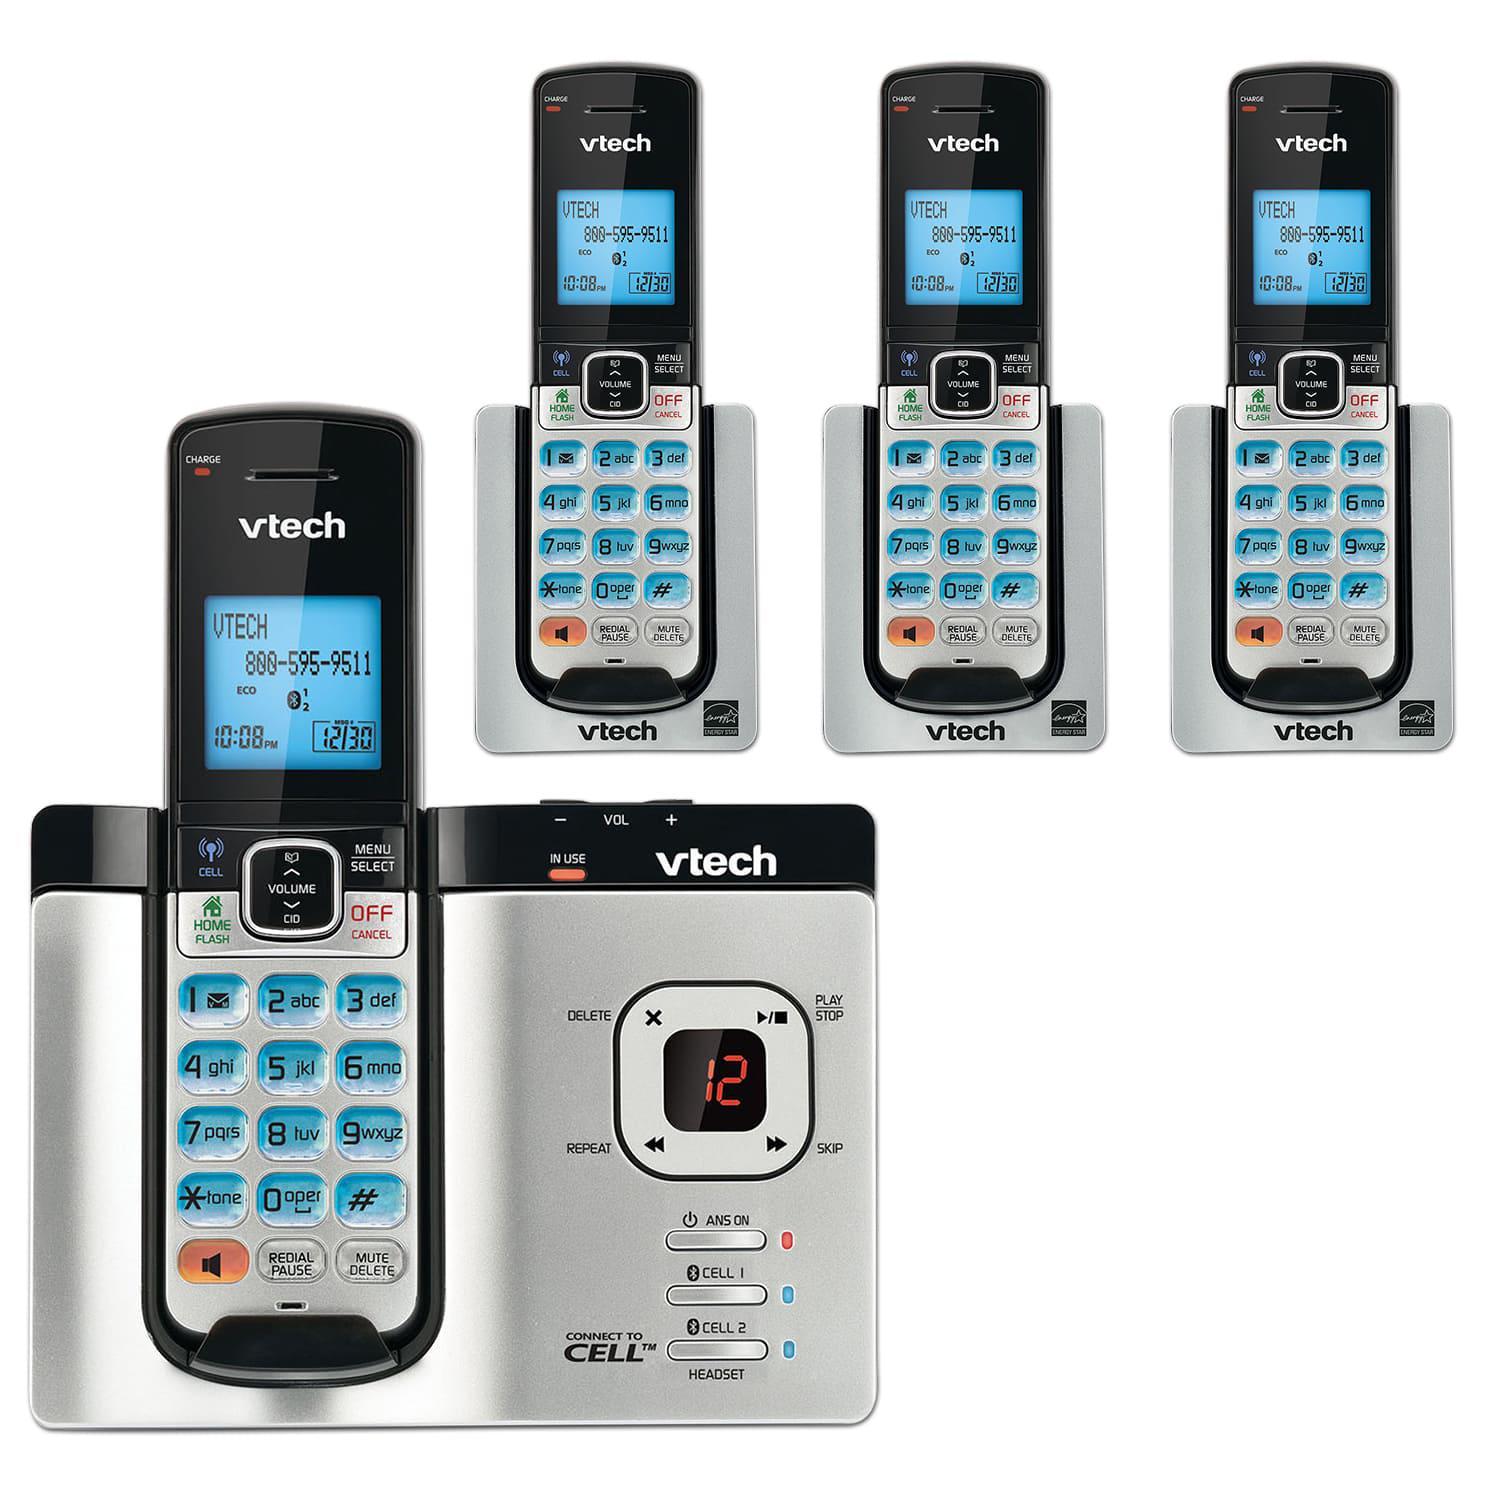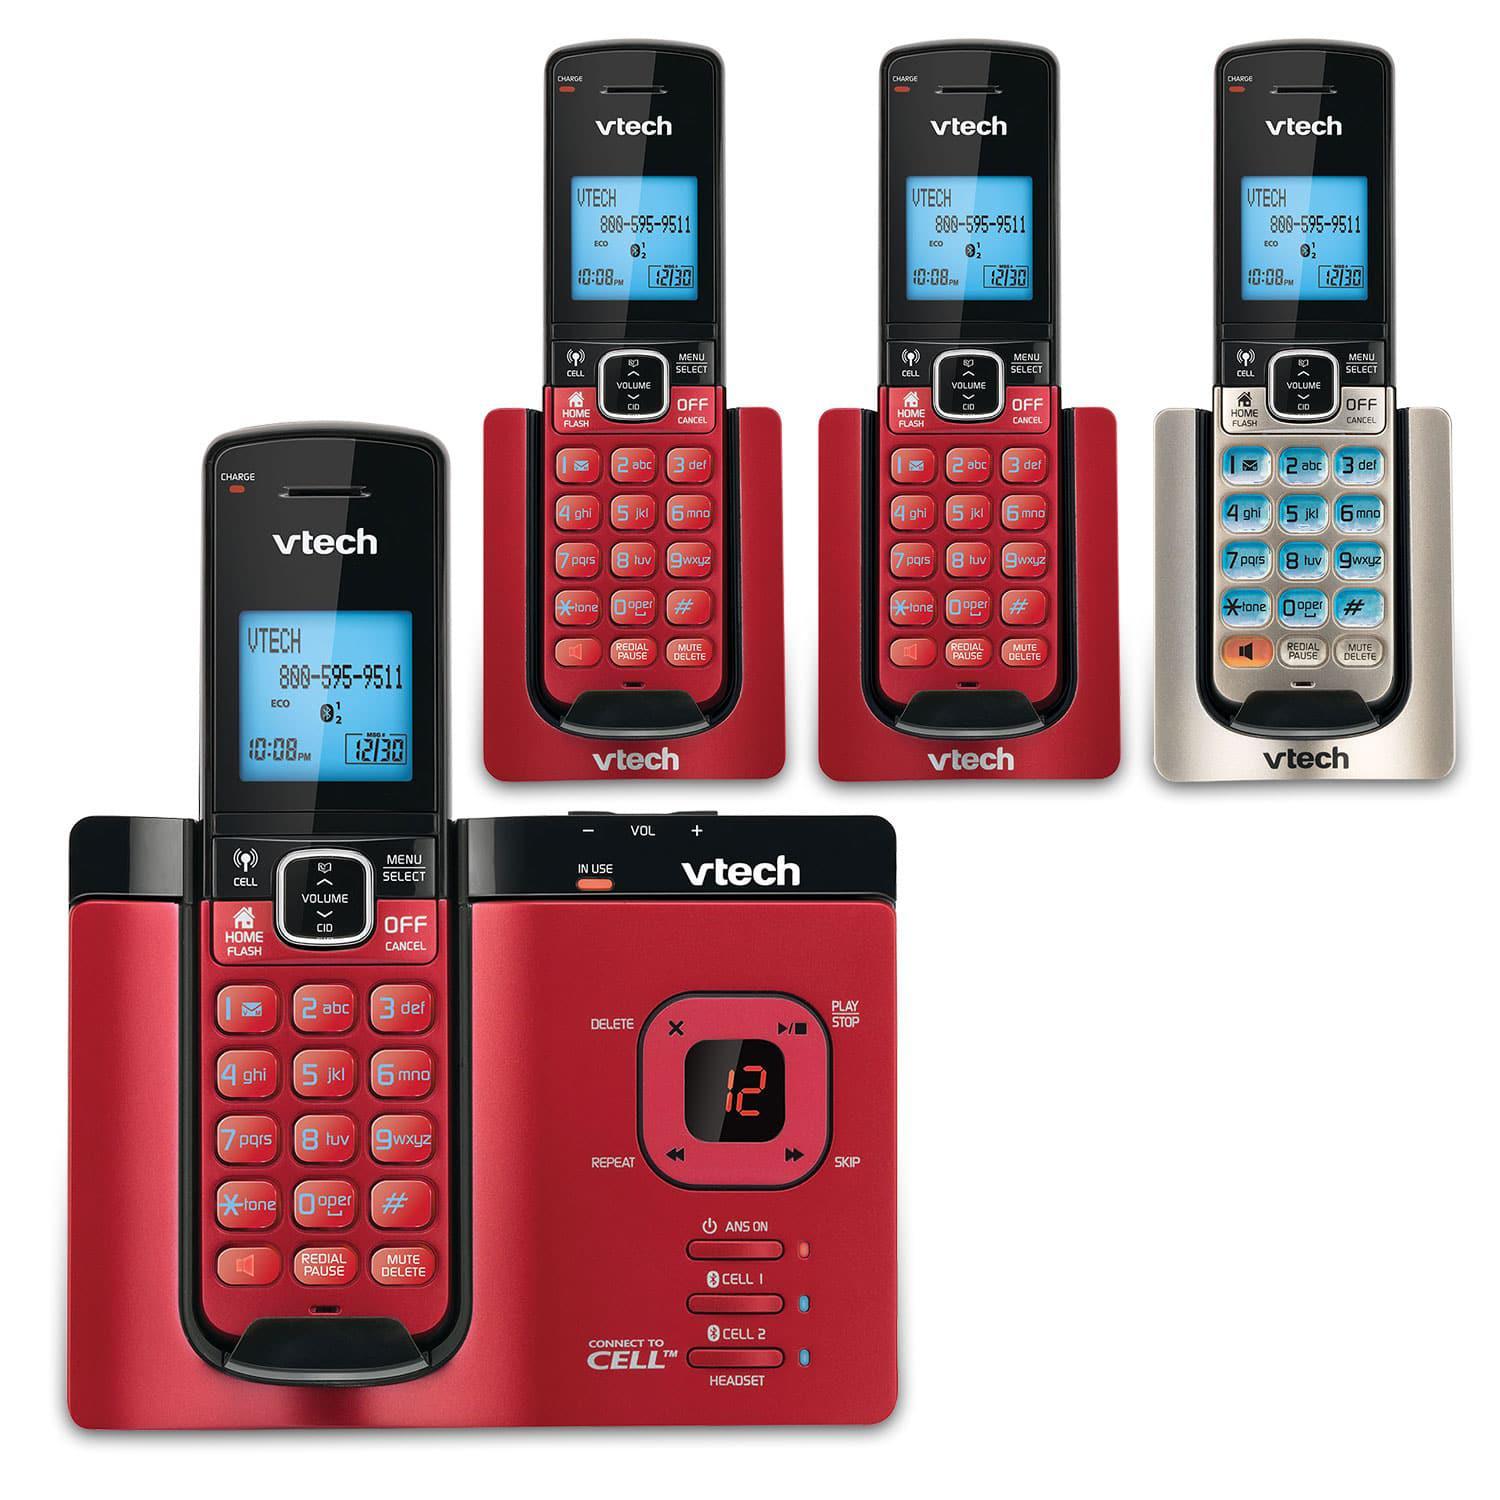The first image is the image on the left, the second image is the image on the right. Analyze the images presented: Is the assertion "Each image includes at least three 'extra' handsets resting in their bases and at least one main handset on a larger base." valid? Answer yes or no. Yes. 